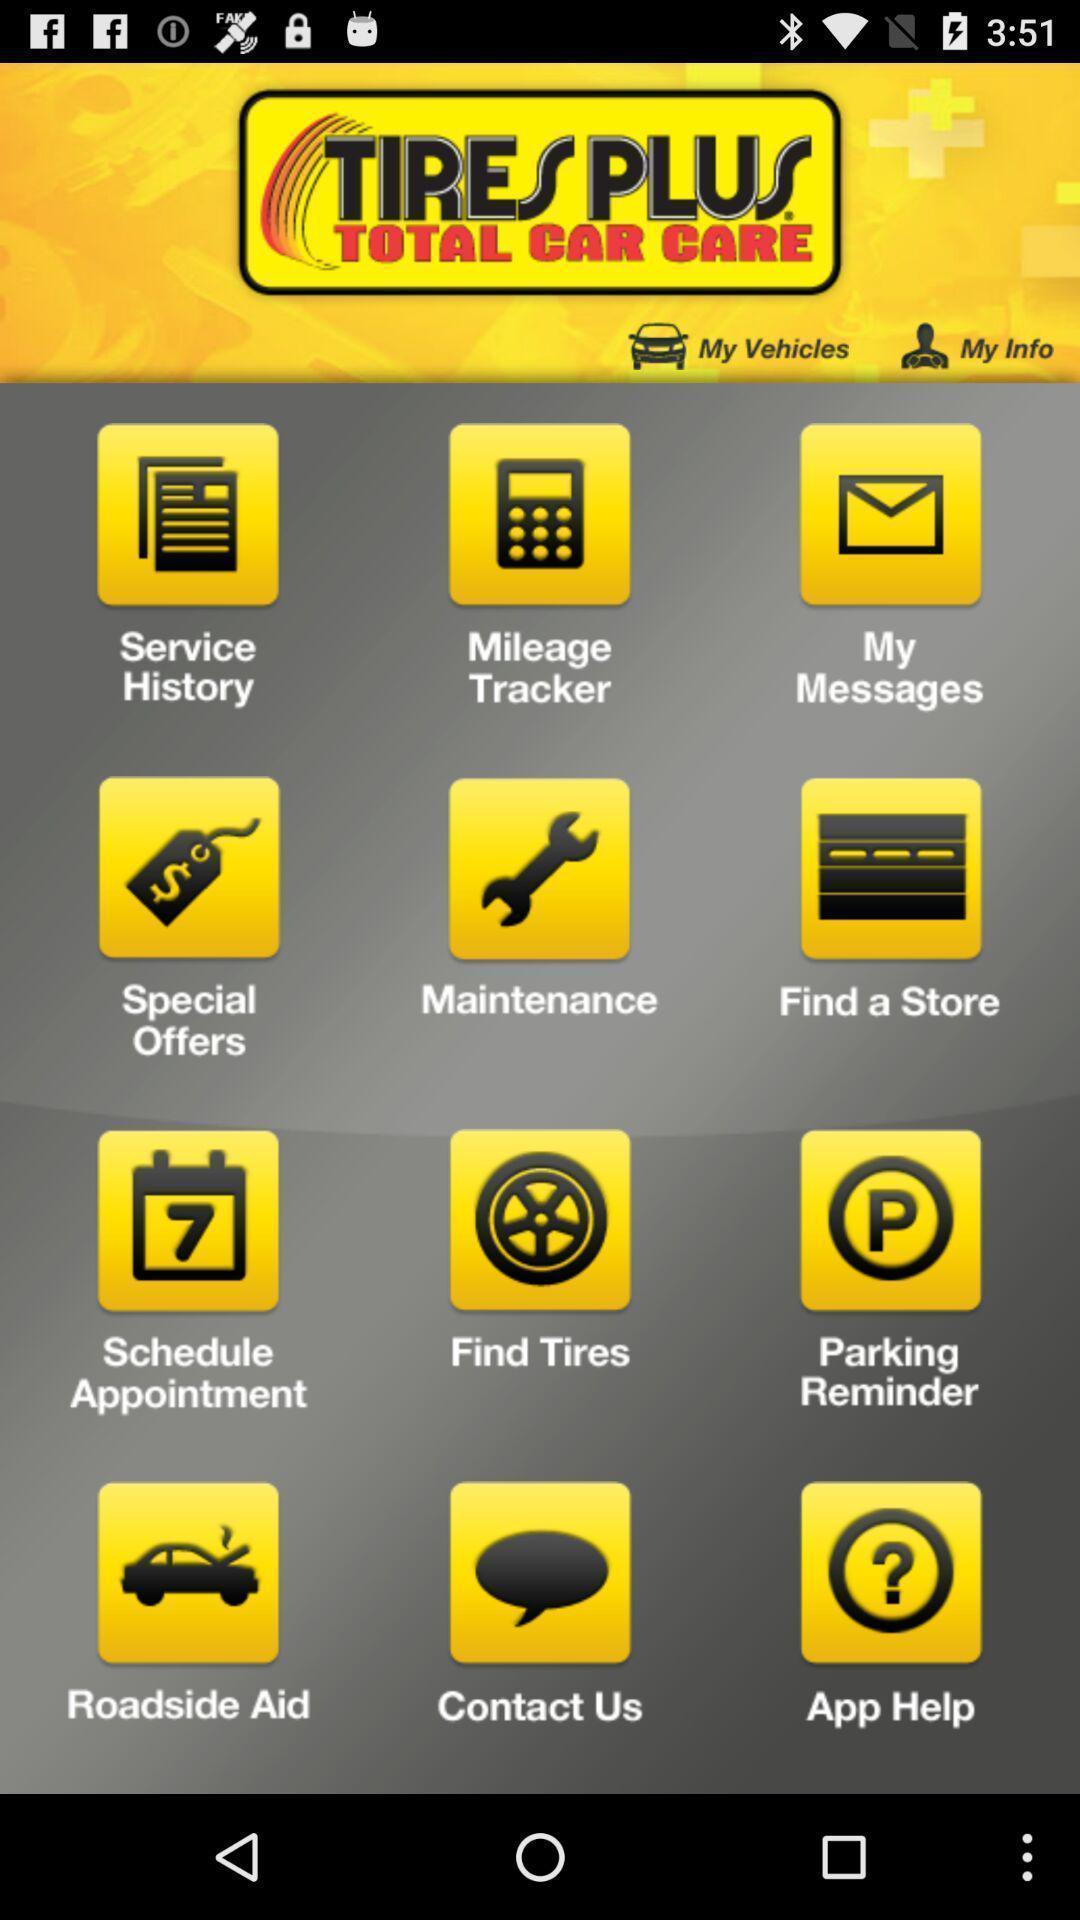Summarize the main components in this picture. Various options displayed of an automobile maintenance app. 